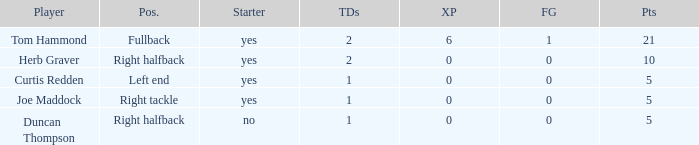Name the most touchdowns for field goals being 1 2.0. 